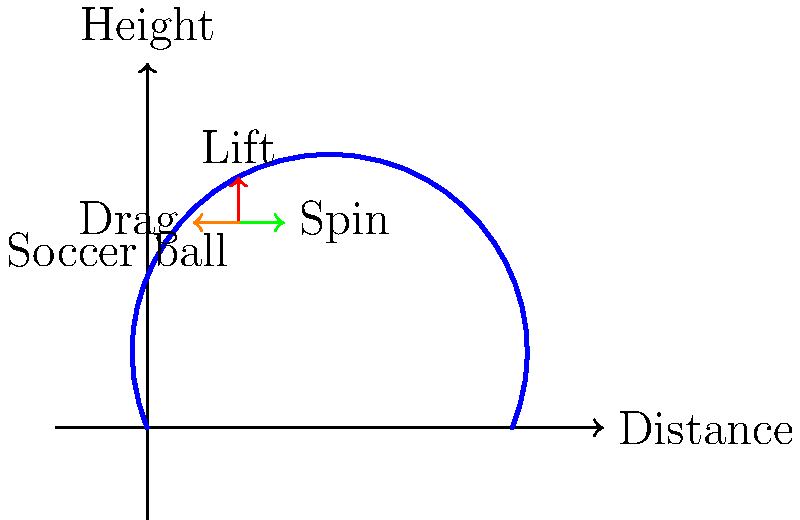As the owner of a local soccer team, you're explaining the physics behind a curved free kick to your fans. When a player kicks a spinning soccer ball, it experiences air resistance and the Magnus effect. Using the diagram, explain how these forces affect the ball's trajectory and why a spinning ball can curve in flight. What advantage does this give to skilled players? 1. Air resistance (drag force):
   - Represented by the orange arrow pointing opposite to the ball's motion.
   - Slows down the ball due to friction with air molecules.
   - Increases with the ball's velocity, following the equation: $F_d = \frac{1}{2}\rho v^2 C_d A$
     where $\rho$ is air density, $v$ is velocity, $C_d$ is drag coefficient, and $A$ is cross-sectional area.

2. Magnus effect (lift force):
   - Represented by the red arrow pointing upward.
   - Caused by the ball's spin creating a pressure difference between the upper and lower surfaces.
   - Force is perpendicular to both the velocity and spin axis.
   - Magnitude depends on spin rate, velocity, and air density: $F_L = \frac{1}{2}\rho v^2 C_L A$
     where $C_L$ is the lift coefficient.

3. Spin-induced side force:
   - Represented by the green arrow pointing sideways.
   - Also a result of the Magnus effect, but causing lateral movement.
   - Direction depends on the spin axis orientation.

4. Resulting trajectory:
   - The blue curve shows the ball's path combining all these forces.
   - Without spin, the ball would follow a simpler parabolic path.
   - With spin, the ball curves in the direction of the spin-induced force.

5. Advantage for skilled players:
   - Can make the ball curve around defensive walls in free kicks.
   - Allows for more unpredictable shots, making it harder for goalkeepers to anticipate.
   - Enables players to bend passes around defenders with greater precision.
Answer: Spinning creates lift and side forces, curving the ball's trajectory and allowing players to bend shots around obstacles. 